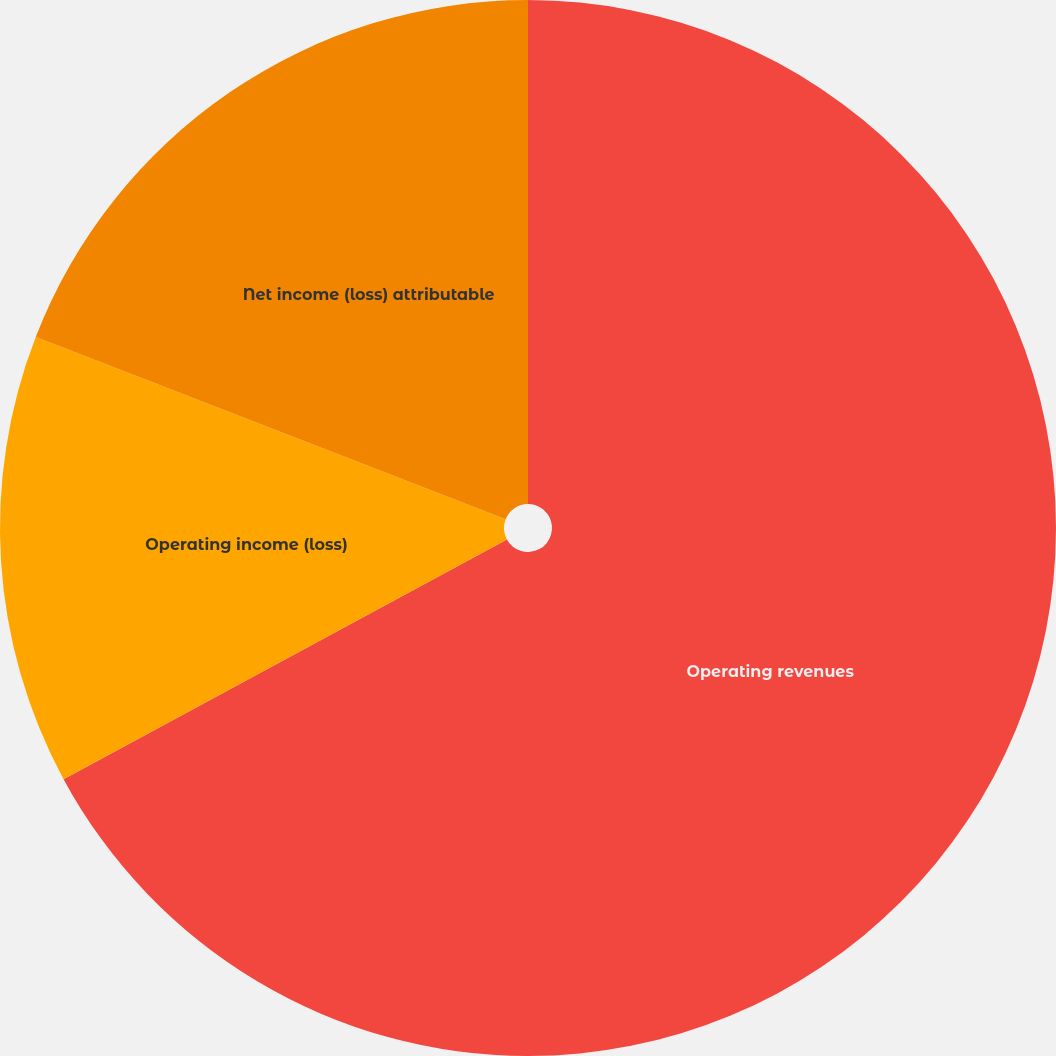Convert chart. <chart><loc_0><loc_0><loc_500><loc_500><pie_chart><fcel>Operating revenues<fcel>Operating income (loss)<fcel>Net income (loss) attributable<nl><fcel>67.11%<fcel>13.78%<fcel>19.11%<nl></chart> 